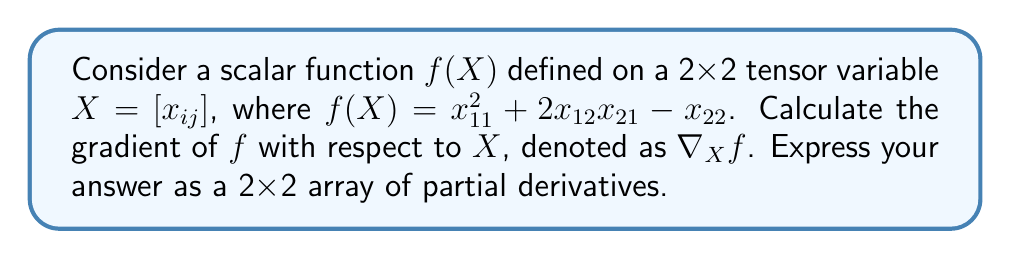Provide a solution to this math problem. To calculate the gradient of a scalar function with respect to a tensor variable, we need to compute the partial derivatives of the function with respect to each element of the tensor. This process is similar to creating a multi-dimensional array of partial derivatives in JavaScript.

Let's break it down step-by-step:

1. Identify the elements of the tensor $X$:
   $$X = \begin{bmatrix}
   x_{11} & x_{12} \\
   x_{21} & x_{22}
   \end{bmatrix}$$

2. Calculate the partial derivative with respect to $x_{11}$:
   $$\frac{\partial f}{\partial x_{11}} = 2x_{11}$$

3. Calculate the partial derivative with respect to $x_{12}$:
   $$\frac{\partial f}{\partial x_{12}} = 2x_{21}$$

4. Calculate the partial derivative with respect to $x_{21}$:
   $$\frac{\partial f}{\partial x_{21}} = 2x_{12}$$

5. Calculate the partial derivative with respect to $x_{22}$:
   $$\frac{\partial f}{\partial x_{22}} = -1$$

6. Arrange the partial derivatives in a 2x2 array to form the gradient:
   $$\nabla_X f = \begin{bmatrix}
   \frac{\partial f}{\partial x_{11}} & \frac{\partial f}{\partial x_{12}} \\
   \frac{\partial f}{\partial x_{21}} & \frac{\partial f}{\partial x_{22}}
   \end{bmatrix}$$

7. Substitute the calculated partial derivatives:
   $$\nabla_X f = \begin{bmatrix}
   2x_{11} & 2x_{21} \\
   2x_{12} & -1
   \end{bmatrix}$$

This result can be thought of as a 2D array in JavaScript, where each element represents the rate of change of the function with respect to the corresponding element of the tensor $X$.
Answer: $$\nabla_X f = \begin{bmatrix}
2x_{11} & 2x_{21} \\
2x_{12} & -1
\end{bmatrix}$$ 